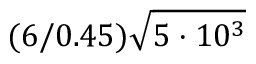Convert formula to latex. <formula><loc_0><loc_0><loc_500><loc_500>( 6 / 0 . 4 5 ) \sqrt { 5 \cdot 1 0 ^ { 3 } }</formula> 